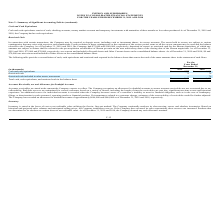According to Inpixon's financial document, What does cash and cash equivalents consist of? cash, checking accounts, money market accounts and temporary investments with maturities of three months or less when purchased.. The document states: "h Equivalents Cash and cash equivalents consist of cash, checking accounts, money market accounts and temporary investments with maturities of three m..." Also, What was the amount in escrow as restricted cash at 2019 and 2018 respectively? The document shows two values: 72,000 and 140,000. From the document: "r 31, 2019 and 2018, the Company had $72,000 and $140,000, respectively, deposited in escrow as restricted cash for the Shoom acquisition, of which an..." Also, What was the Cash and cash equivalents in 2019 and 2018 respectively? The document shows two values: $4,777 and $1,008 (in thousands). From the document: "Cash and cash equivalents $ 4,777 $ 1,008 Cash and cash equivalents $ 4,777 $ 1,008..." Additionally, In which year  was Restricted cash included in other assets, noncurrent less than 70 thousands? According to the financial document, 2019. The relevant text states: "(in thousands) 2019 2018..." Also, can you calculate: What is the average Restricted cash for 2018 and 2019? To answer this question, I need to perform calculations using the financial data. The calculation is: (72 + 70) / 2, which equals 71 (in thousands). This is based on the information: "Restricted cash 72 70 Restricted cash 72 70..." The key data points involved are: 70, 72. Also, can you calculate: What was the change in the Cash and cash equivalents from 2018 to 2019? Based on the calculation: 4,777 - 1,008, the result is 3769 (in thousands). This is based on the information: "Cash and cash equivalents $ 4,777 $ 1,008 Cash and cash equivalents $ 4,777 $ 1,008..." The key data points involved are: 1,008, 4,777. 